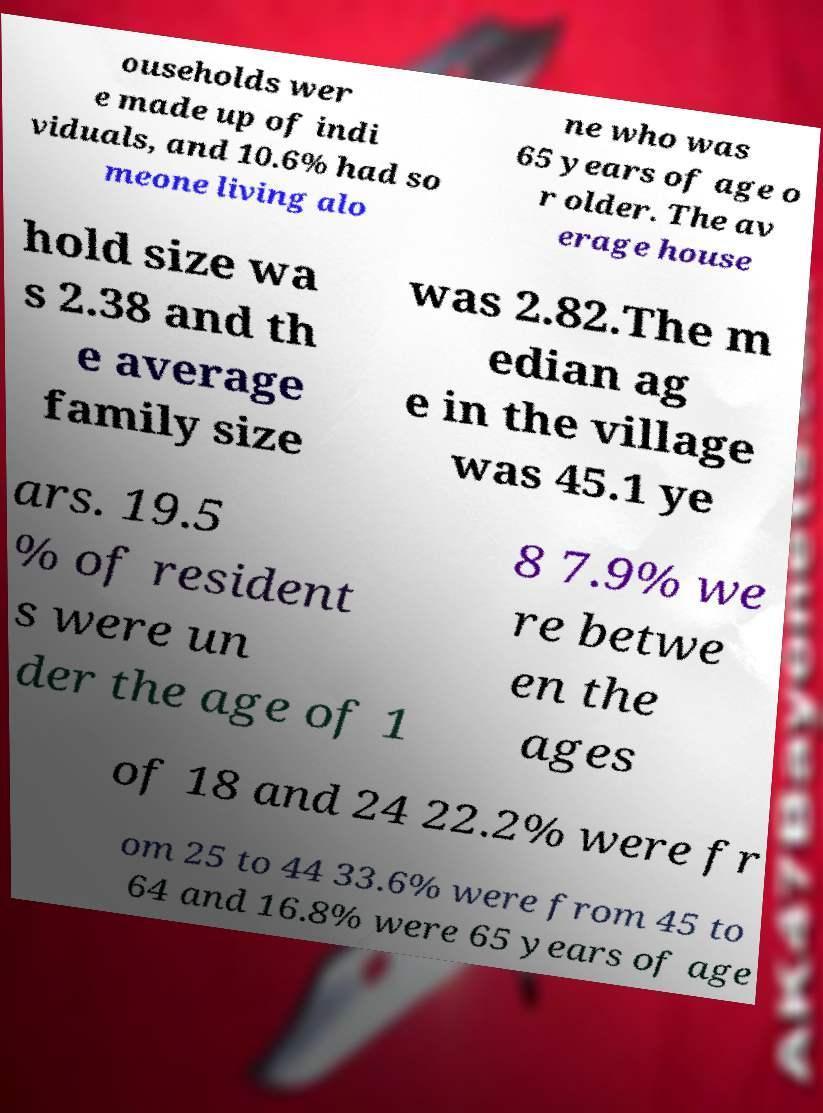Can you accurately transcribe the text from the provided image for me? ouseholds wer e made up of indi viduals, and 10.6% had so meone living alo ne who was 65 years of age o r older. The av erage house hold size wa s 2.38 and th e average family size was 2.82.The m edian ag e in the village was 45.1 ye ars. 19.5 % of resident s were un der the age of 1 8 7.9% we re betwe en the ages of 18 and 24 22.2% were fr om 25 to 44 33.6% were from 45 to 64 and 16.8% were 65 years of age 